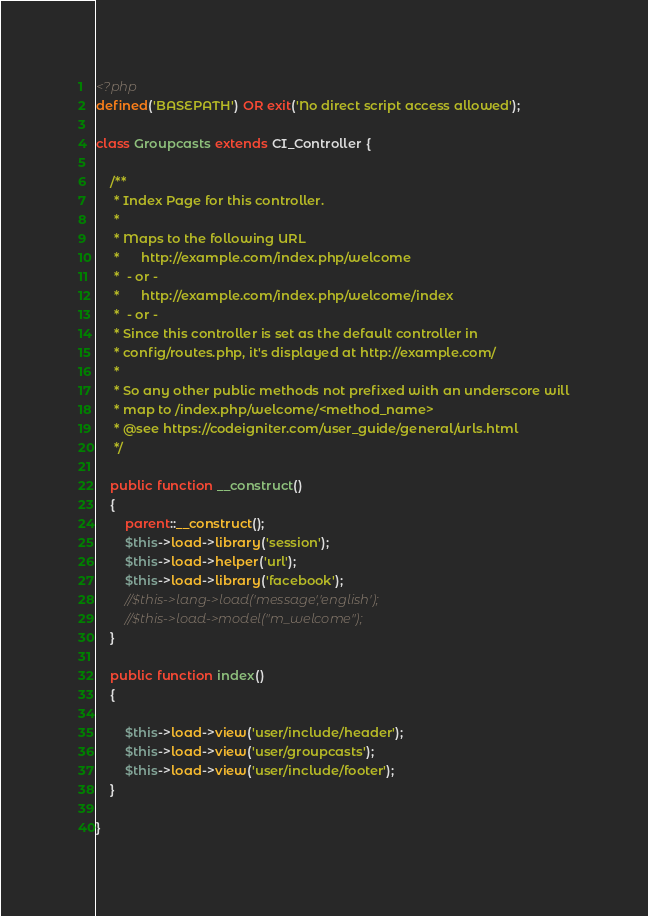<code> <loc_0><loc_0><loc_500><loc_500><_PHP_><?php
defined('BASEPATH') OR exit('No direct script access allowed');

class Groupcasts extends CI_Controller {

	/**
	 * Index Page for this controller.
	 *
	 * Maps to the following URL
	 * 		http://example.com/index.php/welcome
	 *	- or -
	 * 		http://example.com/index.php/welcome/index
	 *	- or -
	 * Since this controller is set as the default controller in
	 * config/routes.php, it's displayed at http://example.com/
	 *
	 * So any other public methods not prefixed with an underscore will
	 * map to /index.php/welcome/<method_name>
	 * @see https://codeigniter.com/user_guide/general/urls.html
	 */
	
	public function __construct()
    {
        parent::__construct();
		$this->load->library('session');
    	$this->load->helper('url');
		$this->load->library('facebook');
		//$this->lang->load('message','english');
		//$this->load->model("m_welcome");
    }
	
	public function index()
	{
		
		$this->load->view('user/include/header');
		$this->load->view('user/groupcasts');
		$this->load->view('user/include/footer');
	}
	
}
</code> 